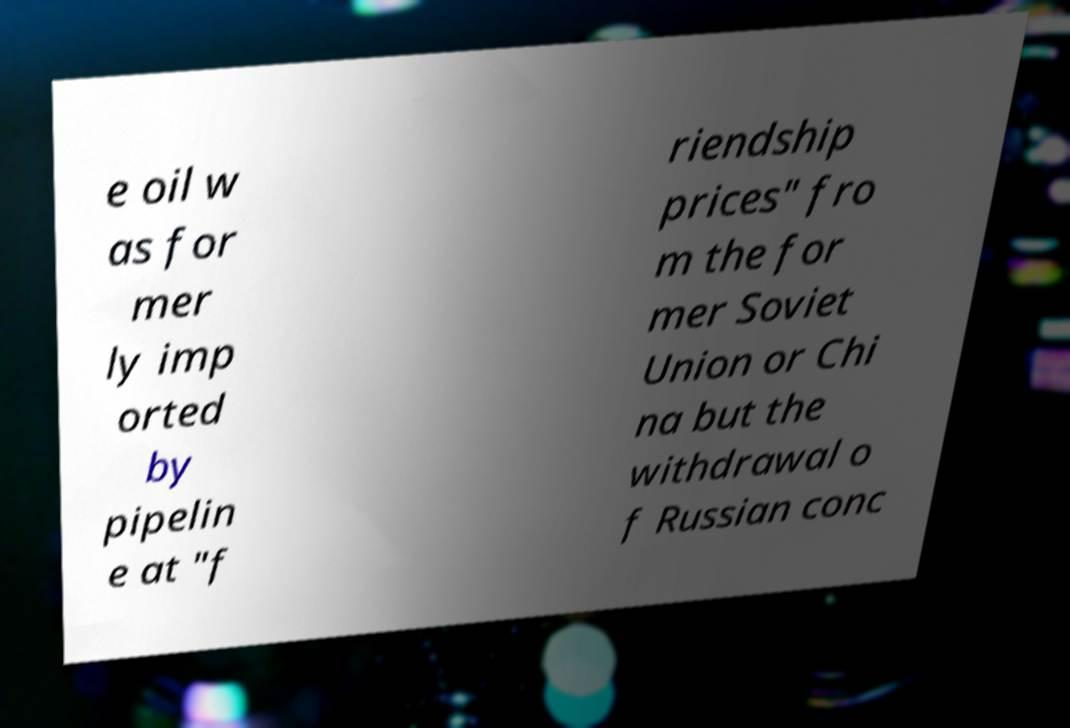What messages or text are displayed in this image? I need them in a readable, typed format. e oil w as for mer ly imp orted by pipelin e at "f riendship prices" fro m the for mer Soviet Union or Chi na but the withdrawal o f Russian conc 